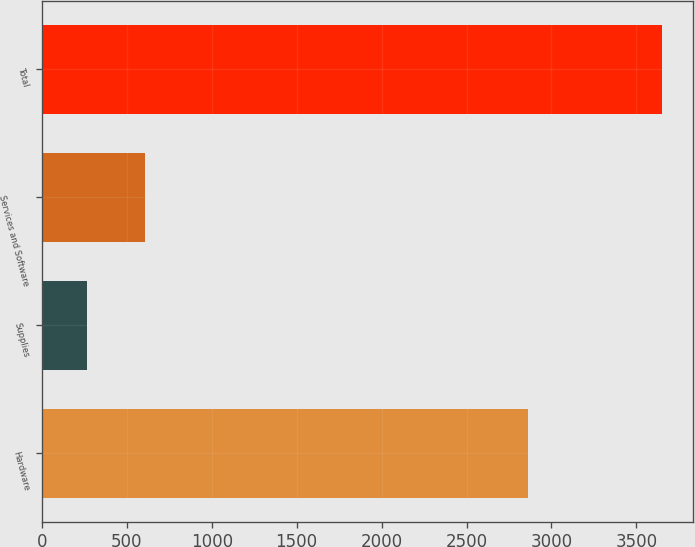<chart> <loc_0><loc_0><loc_500><loc_500><bar_chart><fcel>Hardware<fcel>Supplies<fcel>Services and Software<fcel>Total<nl><fcel>2863<fcel>268<fcel>606.2<fcel>3650<nl></chart> 